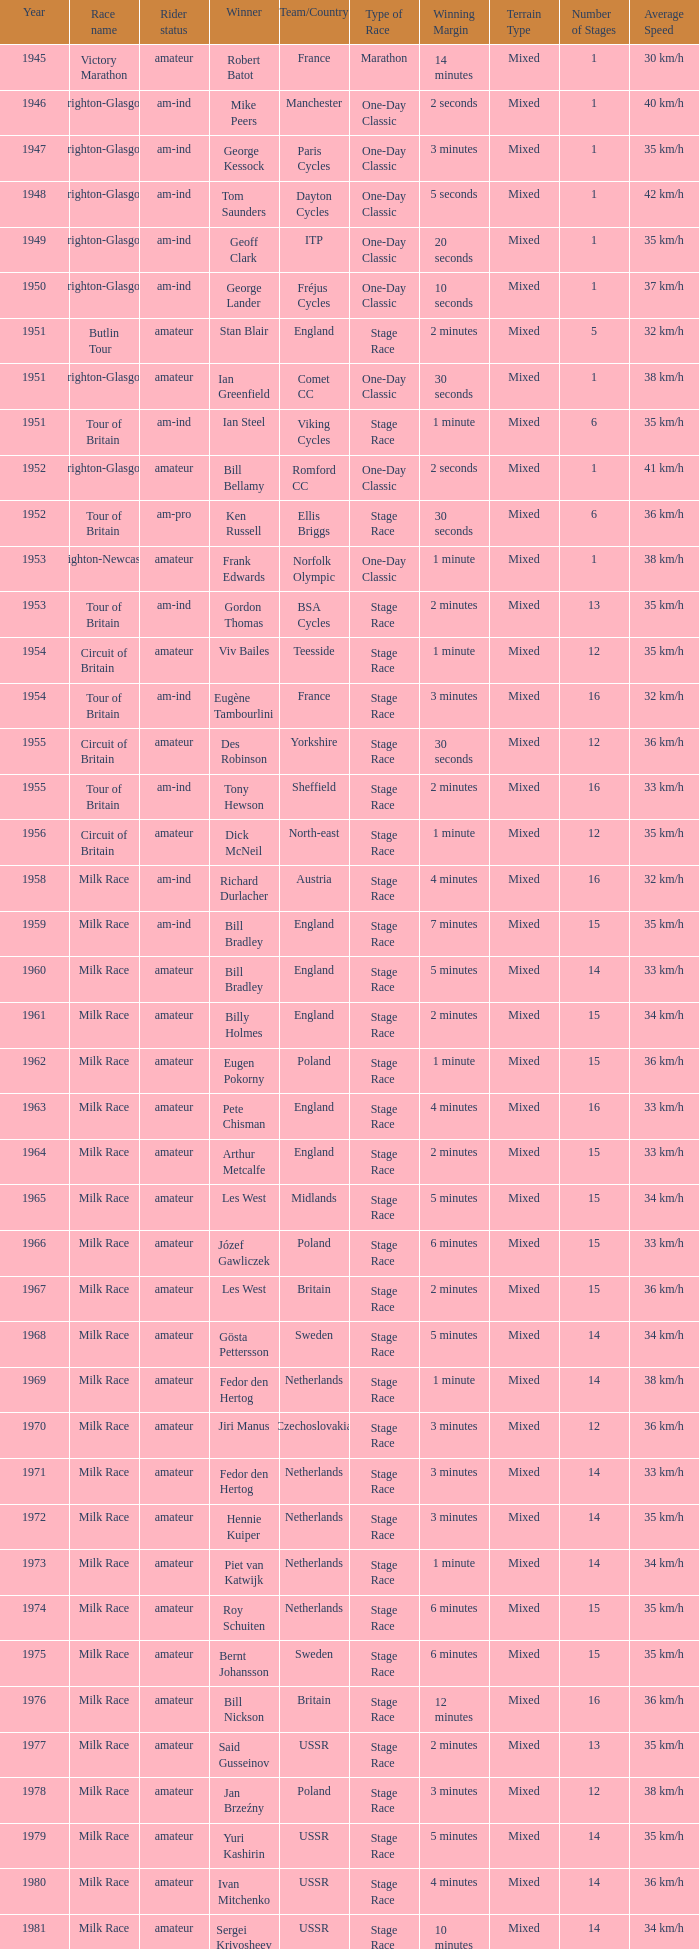Who was the winner in 1973 with an amateur rider status? Piet van Katwijk. 